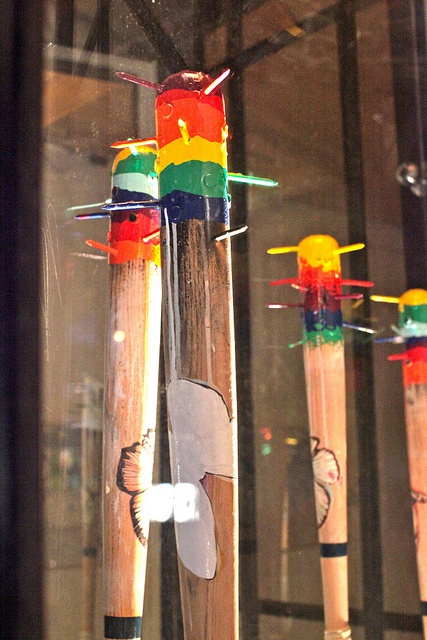Describe the objects in this image and their specific colors. I can see baseball bat in black, brown, darkgray, tan, and white tones, baseball bat in black, salmon, and tan tones, baseball bat in black, tan, and gold tones, and baseball bat in black, salmon, red, and brown tones in this image. 